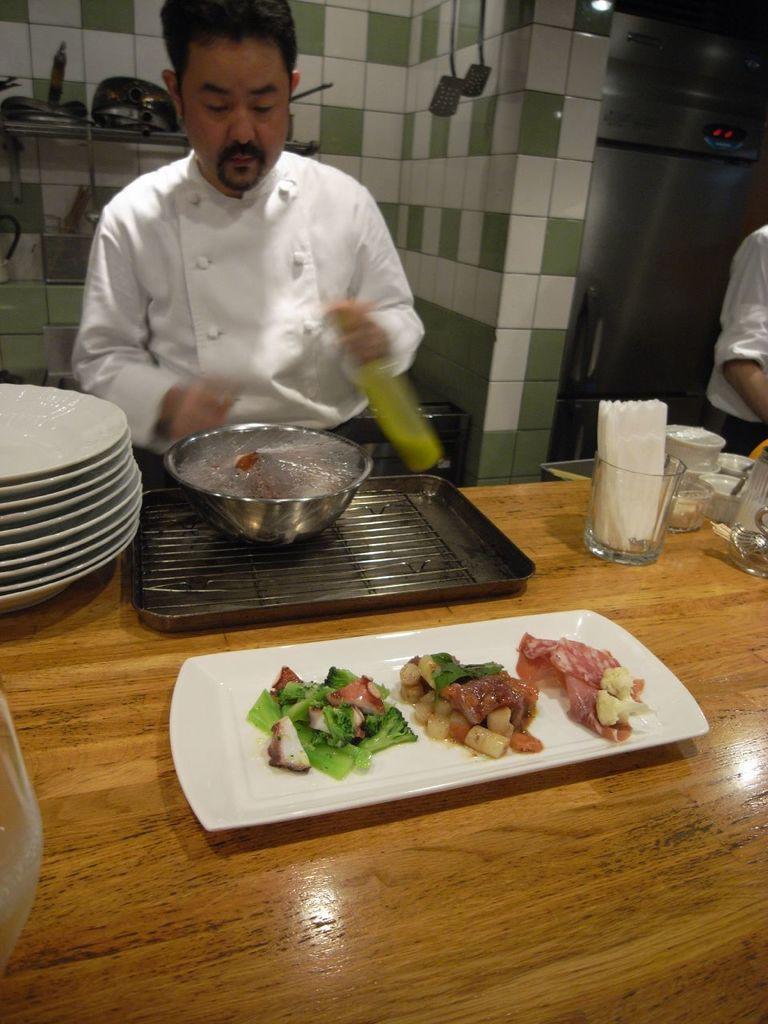Can you describe this image briefly? In this picture we can see a table and on the table there are plates, tray, bowls and some objects. Behind the table there are two people standing and a man is holding an object. On the right side of the people there is a refrigerator. Behind the man there is a wall with some objects. 